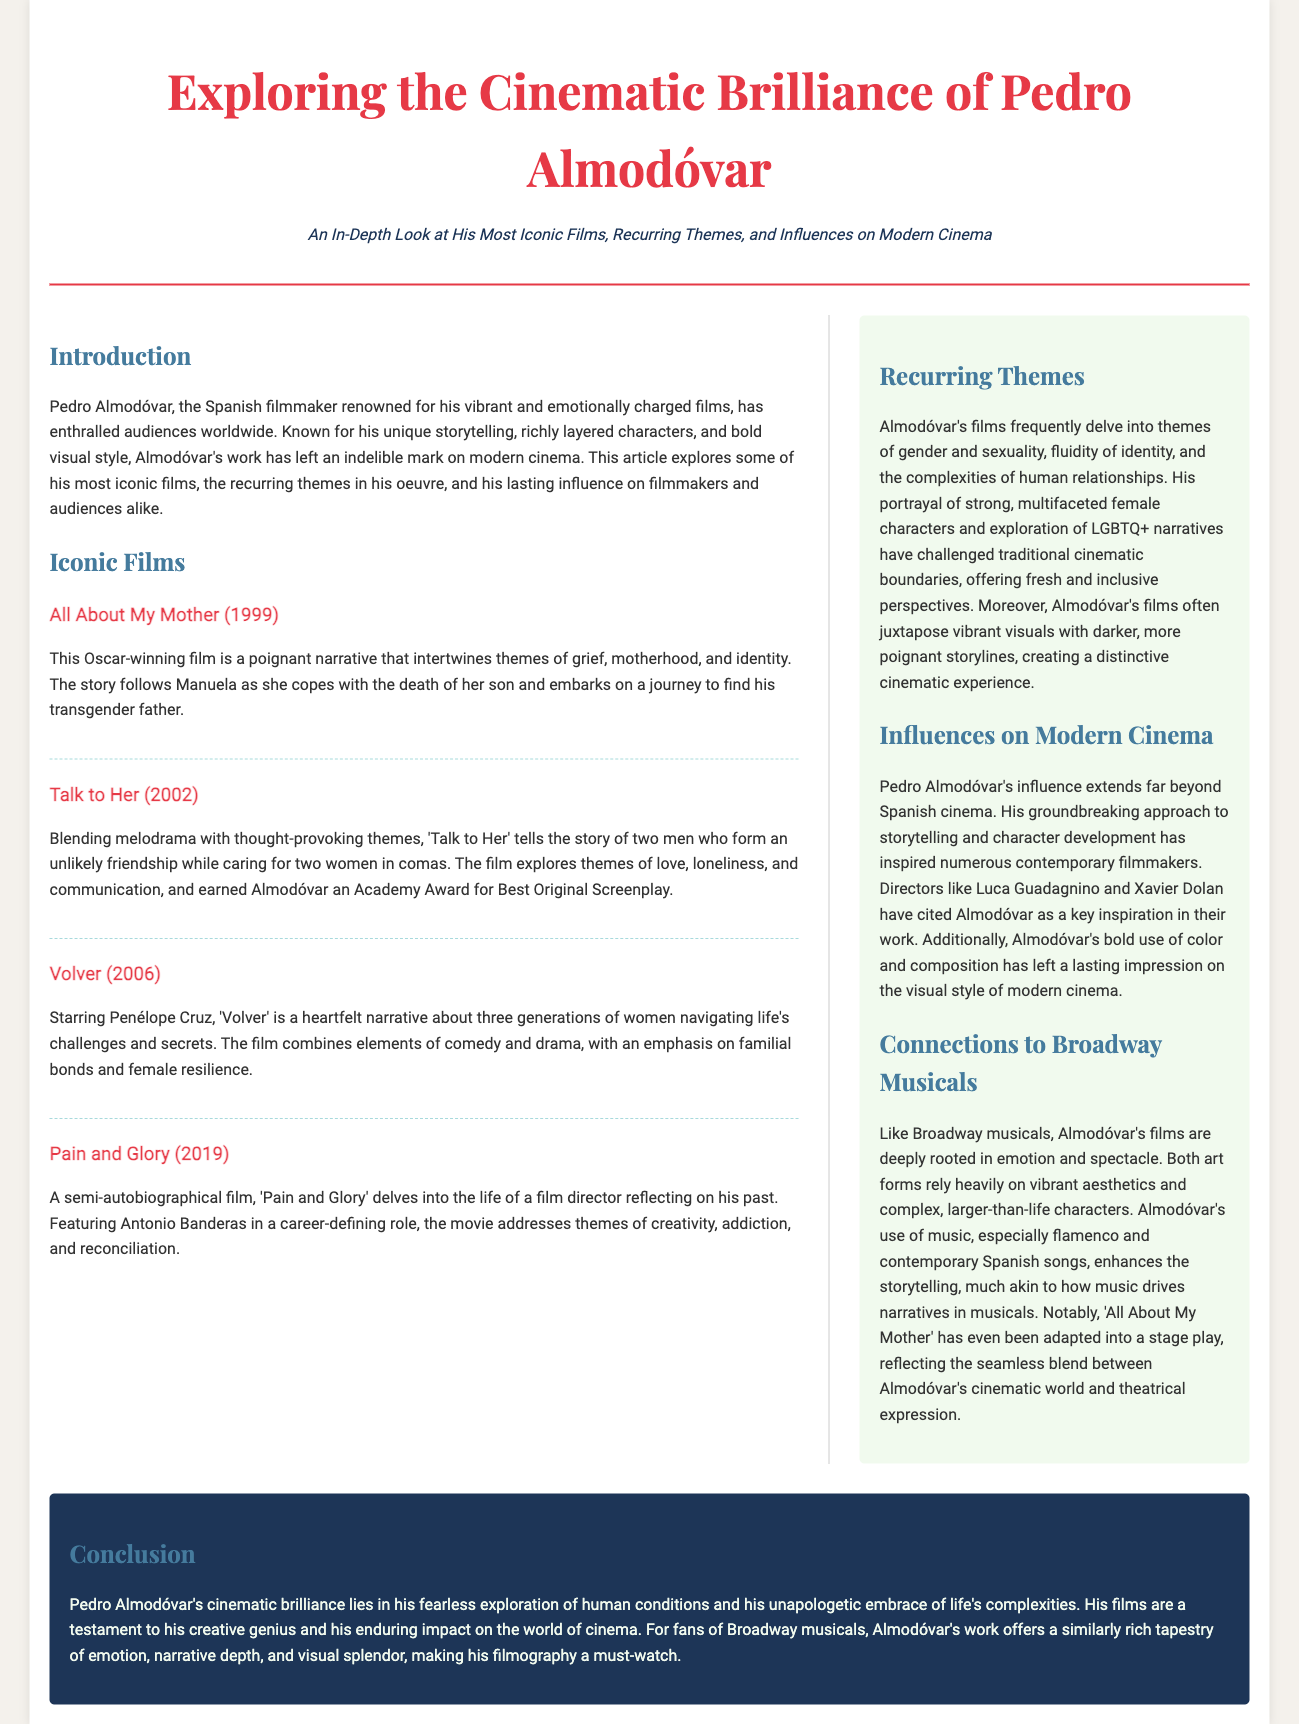what year was "All About My Mother" released? The film "All About My Mother" was released in 1999, as mentioned in the document.
Answer: 1999 who starred in "Volver"? The document states that Penélope Cruz starred in "Volver."
Answer: Penélope Cruz what is a recurring theme in Almodóvar's films? The document mentions themes of gender and sexuality, fluidity of identity, and the complexities of human relationships as recurring themes in Almodóvar's films.
Answer: gender and sexuality which film earned Almodóvar an Academy Award? The film "Talk to Her" earned Almodóvar an Academy Award for Best Original Screenplay, as noted in the text.
Answer: Talk to Her how does Almodóvar's use of music relate to Broadway? The document explains that both Almodóvar's films and Broadway musicals enhance storytelling through music.
Answer: enhances the storytelling who cited Almodóvar as an inspiration? The document notes that directors like Luca Guadagnino and Xavier Dolan have cited Almodóvar as a key inspiration.
Answer: Luca Guadagnino and Xavier Dolan what type of film is "Pain and Glory"? "Pain and Glory" is described as a semi-autobiographical film in the article.
Answer: semi-autobiographical which film has been adapted into a stage play? The document states that "All About My Mother" has been adapted into a stage play.
Answer: All About My Mother 